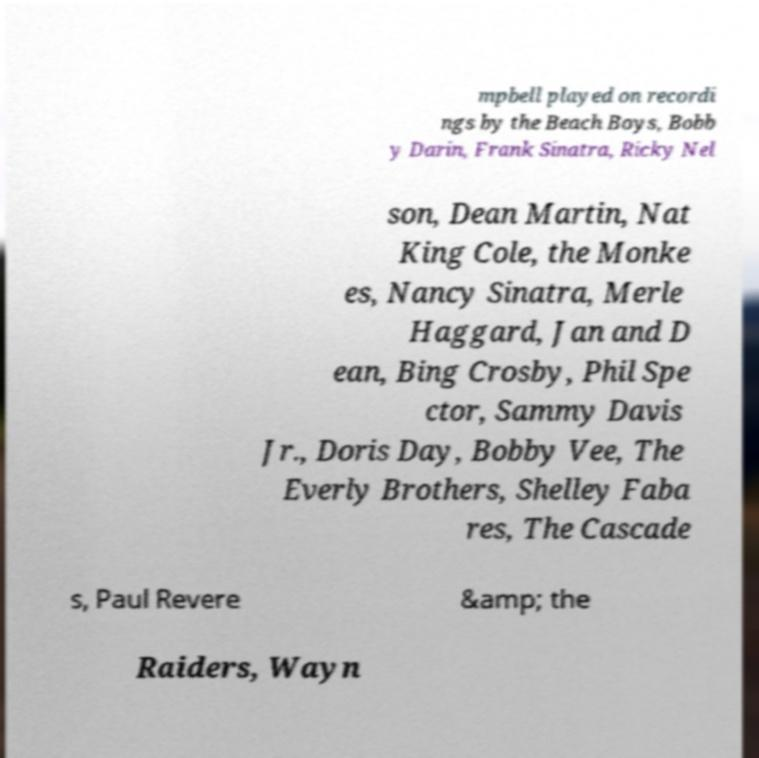Please identify and transcribe the text found in this image. mpbell played on recordi ngs by the Beach Boys, Bobb y Darin, Frank Sinatra, Ricky Nel son, Dean Martin, Nat King Cole, the Monke es, Nancy Sinatra, Merle Haggard, Jan and D ean, Bing Crosby, Phil Spe ctor, Sammy Davis Jr., Doris Day, Bobby Vee, The Everly Brothers, Shelley Faba res, The Cascade s, Paul Revere &amp; the Raiders, Wayn 